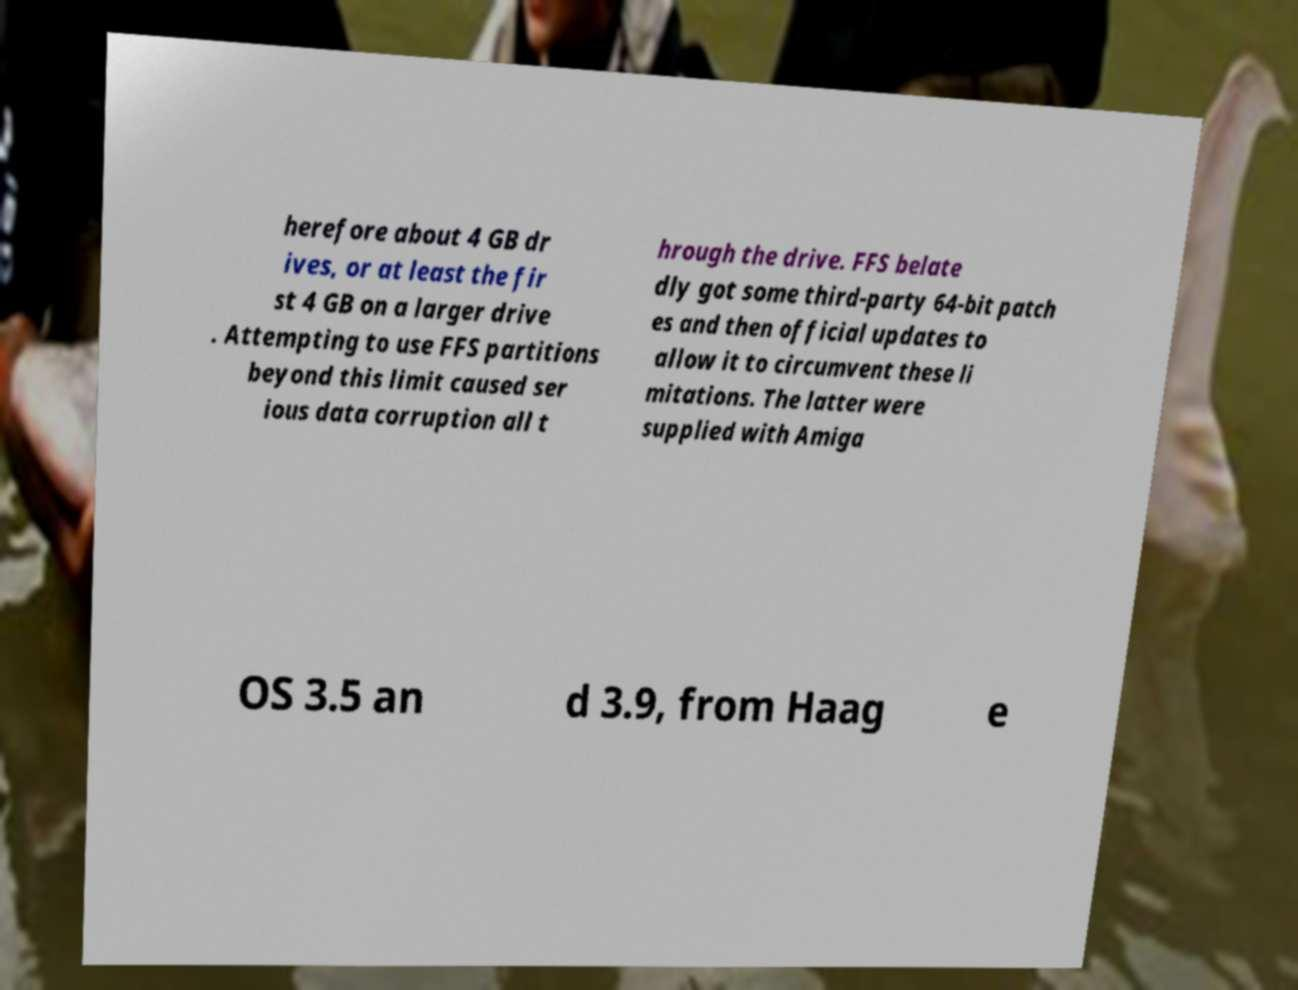There's text embedded in this image that I need extracted. Can you transcribe it verbatim? herefore about 4 GB dr ives, or at least the fir st 4 GB on a larger drive . Attempting to use FFS partitions beyond this limit caused ser ious data corruption all t hrough the drive. FFS belate dly got some third-party 64-bit patch es and then official updates to allow it to circumvent these li mitations. The latter were supplied with Amiga OS 3.5 an d 3.9, from Haag e 